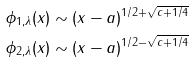Convert formula to latex. <formula><loc_0><loc_0><loc_500><loc_500>\phi _ { 1 , \lambda } ( x ) & \sim ( x - a ) ^ { 1 / 2 + \sqrt { c + 1 / 4 } } \\ \phi _ { 2 , \lambda } ( x ) & \sim ( x - a ) ^ { 1 / 2 - \sqrt { c + 1 / 4 } }</formula> 